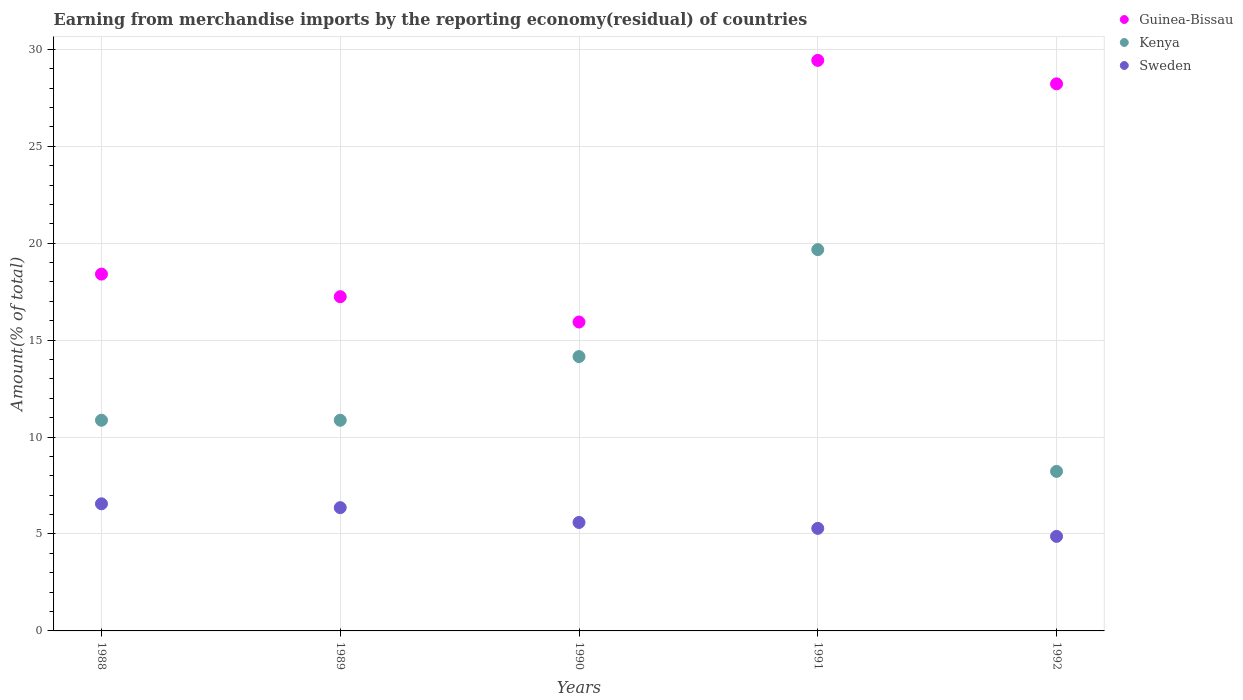What is the percentage of amount earned from merchandise imports in Sweden in 1990?
Give a very brief answer. 5.59. Across all years, what is the maximum percentage of amount earned from merchandise imports in Kenya?
Ensure brevity in your answer.  19.67. Across all years, what is the minimum percentage of amount earned from merchandise imports in Kenya?
Keep it short and to the point. 8.23. In which year was the percentage of amount earned from merchandise imports in Kenya maximum?
Ensure brevity in your answer.  1991. In which year was the percentage of amount earned from merchandise imports in Sweden minimum?
Make the answer very short. 1992. What is the total percentage of amount earned from merchandise imports in Guinea-Bissau in the graph?
Offer a terse response. 109.22. What is the difference between the percentage of amount earned from merchandise imports in Sweden in 1988 and that in 1989?
Make the answer very short. 0.2. What is the difference between the percentage of amount earned from merchandise imports in Guinea-Bissau in 1988 and the percentage of amount earned from merchandise imports in Kenya in 1990?
Your answer should be very brief. 4.25. What is the average percentage of amount earned from merchandise imports in Sweden per year?
Your answer should be compact. 5.73. In the year 1990, what is the difference between the percentage of amount earned from merchandise imports in Kenya and percentage of amount earned from merchandise imports in Guinea-Bissau?
Give a very brief answer. -1.78. In how many years, is the percentage of amount earned from merchandise imports in Guinea-Bissau greater than 25 %?
Offer a terse response. 2. What is the ratio of the percentage of amount earned from merchandise imports in Sweden in 1989 to that in 1992?
Offer a very short reply. 1.3. What is the difference between the highest and the second highest percentage of amount earned from merchandise imports in Kenya?
Offer a terse response. 5.52. What is the difference between the highest and the lowest percentage of amount earned from merchandise imports in Guinea-Bissau?
Offer a very short reply. 13.49. Does the percentage of amount earned from merchandise imports in Guinea-Bissau monotonically increase over the years?
Provide a succinct answer. No. Is the percentage of amount earned from merchandise imports in Kenya strictly greater than the percentage of amount earned from merchandise imports in Sweden over the years?
Offer a very short reply. Yes. How many years are there in the graph?
Keep it short and to the point. 5. What is the difference between two consecutive major ticks on the Y-axis?
Keep it short and to the point. 5. Does the graph contain grids?
Keep it short and to the point. Yes. How many legend labels are there?
Provide a short and direct response. 3. What is the title of the graph?
Make the answer very short. Earning from merchandise imports by the reporting economy(residual) of countries. Does "Central Europe" appear as one of the legend labels in the graph?
Your answer should be compact. No. What is the label or title of the Y-axis?
Make the answer very short. Amount(% of total). What is the Amount(% of total) in Guinea-Bissau in 1988?
Provide a succinct answer. 18.4. What is the Amount(% of total) of Kenya in 1988?
Provide a short and direct response. 10.87. What is the Amount(% of total) of Sweden in 1988?
Your answer should be compact. 6.56. What is the Amount(% of total) of Guinea-Bissau in 1989?
Provide a short and direct response. 17.24. What is the Amount(% of total) in Kenya in 1989?
Offer a terse response. 10.87. What is the Amount(% of total) of Sweden in 1989?
Your response must be concise. 6.36. What is the Amount(% of total) of Guinea-Bissau in 1990?
Offer a very short reply. 15.93. What is the Amount(% of total) of Kenya in 1990?
Keep it short and to the point. 14.15. What is the Amount(% of total) of Sweden in 1990?
Ensure brevity in your answer.  5.59. What is the Amount(% of total) in Guinea-Bissau in 1991?
Provide a succinct answer. 29.43. What is the Amount(% of total) of Kenya in 1991?
Your answer should be compact. 19.67. What is the Amount(% of total) of Sweden in 1991?
Your answer should be compact. 5.29. What is the Amount(% of total) of Guinea-Bissau in 1992?
Your answer should be very brief. 28.22. What is the Amount(% of total) in Kenya in 1992?
Provide a succinct answer. 8.23. What is the Amount(% of total) in Sweden in 1992?
Your response must be concise. 4.88. Across all years, what is the maximum Amount(% of total) in Guinea-Bissau?
Your answer should be compact. 29.43. Across all years, what is the maximum Amount(% of total) in Kenya?
Offer a terse response. 19.67. Across all years, what is the maximum Amount(% of total) of Sweden?
Keep it short and to the point. 6.56. Across all years, what is the minimum Amount(% of total) of Guinea-Bissau?
Your answer should be very brief. 15.93. Across all years, what is the minimum Amount(% of total) in Kenya?
Provide a short and direct response. 8.23. Across all years, what is the minimum Amount(% of total) of Sweden?
Ensure brevity in your answer.  4.88. What is the total Amount(% of total) in Guinea-Bissau in the graph?
Provide a succinct answer. 109.22. What is the total Amount(% of total) of Kenya in the graph?
Provide a succinct answer. 63.78. What is the total Amount(% of total) of Sweden in the graph?
Make the answer very short. 28.67. What is the difference between the Amount(% of total) of Guinea-Bissau in 1988 and that in 1989?
Provide a succinct answer. 1.16. What is the difference between the Amount(% of total) of Sweden in 1988 and that in 1989?
Your answer should be compact. 0.2. What is the difference between the Amount(% of total) of Guinea-Bissau in 1988 and that in 1990?
Keep it short and to the point. 2.47. What is the difference between the Amount(% of total) of Kenya in 1988 and that in 1990?
Provide a succinct answer. -3.28. What is the difference between the Amount(% of total) of Sweden in 1988 and that in 1990?
Your answer should be compact. 0.96. What is the difference between the Amount(% of total) of Guinea-Bissau in 1988 and that in 1991?
Provide a short and direct response. -11.02. What is the difference between the Amount(% of total) in Kenya in 1988 and that in 1991?
Your answer should be compact. -8.8. What is the difference between the Amount(% of total) in Sweden in 1988 and that in 1991?
Ensure brevity in your answer.  1.27. What is the difference between the Amount(% of total) of Guinea-Bissau in 1988 and that in 1992?
Give a very brief answer. -9.81. What is the difference between the Amount(% of total) of Kenya in 1988 and that in 1992?
Make the answer very short. 2.64. What is the difference between the Amount(% of total) in Sweden in 1988 and that in 1992?
Offer a terse response. 1.68. What is the difference between the Amount(% of total) in Guinea-Bissau in 1989 and that in 1990?
Offer a very short reply. 1.31. What is the difference between the Amount(% of total) in Kenya in 1989 and that in 1990?
Your answer should be very brief. -3.28. What is the difference between the Amount(% of total) of Sweden in 1989 and that in 1990?
Make the answer very short. 0.76. What is the difference between the Amount(% of total) of Guinea-Bissau in 1989 and that in 1991?
Your answer should be very brief. -12.19. What is the difference between the Amount(% of total) in Kenya in 1989 and that in 1991?
Provide a succinct answer. -8.8. What is the difference between the Amount(% of total) in Sweden in 1989 and that in 1991?
Offer a terse response. 1.07. What is the difference between the Amount(% of total) of Guinea-Bissau in 1989 and that in 1992?
Make the answer very short. -10.98. What is the difference between the Amount(% of total) in Kenya in 1989 and that in 1992?
Ensure brevity in your answer.  2.64. What is the difference between the Amount(% of total) of Sweden in 1989 and that in 1992?
Offer a very short reply. 1.48. What is the difference between the Amount(% of total) of Guinea-Bissau in 1990 and that in 1991?
Make the answer very short. -13.49. What is the difference between the Amount(% of total) in Kenya in 1990 and that in 1991?
Provide a succinct answer. -5.52. What is the difference between the Amount(% of total) in Sweden in 1990 and that in 1991?
Your answer should be compact. 0.31. What is the difference between the Amount(% of total) of Guinea-Bissau in 1990 and that in 1992?
Ensure brevity in your answer.  -12.28. What is the difference between the Amount(% of total) of Kenya in 1990 and that in 1992?
Give a very brief answer. 5.92. What is the difference between the Amount(% of total) of Sweden in 1990 and that in 1992?
Ensure brevity in your answer.  0.72. What is the difference between the Amount(% of total) of Guinea-Bissau in 1991 and that in 1992?
Give a very brief answer. 1.21. What is the difference between the Amount(% of total) in Kenya in 1991 and that in 1992?
Provide a short and direct response. 11.44. What is the difference between the Amount(% of total) of Sweden in 1991 and that in 1992?
Provide a succinct answer. 0.41. What is the difference between the Amount(% of total) in Guinea-Bissau in 1988 and the Amount(% of total) in Kenya in 1989?
Your answer should be very brief. 7.54. What is the difference between the Amount(% of total) of Guinea-Bissau in 1988 and the Amount(% of total) of Sweden in 1989?
Make the answer very short. 12.05. What is the difference between the Amount(% of total) in Kenya in 1988 and the Amount(% of total) in Sweden in 1989?
Provide a succinct answer. 4.51. What is the difference between the Amount(% of total) in Guinea-Bissau in 1988 and the Amount(% of total) in Kenya in 1990?
Provide a succinct answer. 4.25. What is the difference between the Amount(% of total) in Guinea-Bissau in 1988 and the Amount(% of total) in Sweden in 1990?
Provide a short and direct response. 12.81. What is the difference between the Amount(% of total) in Kenya in 1988 and the Amount(% of total) in Sweden in 1990?
Provide a succinct answer. 5.27. What is the difference between the Amount(% of total) of Guinea-Bissau in 1988 and the Amount(% of total) of Kenya in 1991?
Ensure brevity in your answer.  -1.26. What is the difference between the Amount(% of total) in Guinea-Bissau in 1988 and the Amount(% of total) in Sweden in 1991?
Offer a terse response. 13.12. What is the difference between the Amount(% of total) in Kenya in 1988 and the Amount(% of total) in Sweden in 1991?
Offer a terse response. 5.58. What is the difference between the Amount(% of total) of Guinea-Bissau in 1988 and the Amount(% of total) of Kenya in 1992?
Your response must be concise. 10.18. What is the difference between the Amount(% of total) of Guinea-Bissau in 1988 and the Amount(% of total) of Sweden in 1992?
Keep it short and to the point. 13.53. What is the difference between the Amount(% of total) of Kenya in 1988 and the Amount(% of total) of Sweden in 1992?
Offer a very short reply. 5.99. What is the difference between the Amount(% of total) in Guinea-Bissau in 1989 and the Amount(% of total) in Kenya in 1990?
Your answer should be very brief. 3.09. What is the difference between the Amount(% of total) of Guinea-Bissau in 1989 and the Amount(% of total) of Sweden in 1990?
Provide a succinct answer. 11.64. What is the difference between the Amount(% of total) of Kenya in 1989 and the Amount(% of total) of Sweden in 1990?
Offer a very short reply. 5.27. What is the difference between the Amount(% of total) of Guinea-Bissau in 1989 and the Amount(% of total) of Kenya in 1991?
Your answer should be very brief. -2.43. What is the difference between the Amount(% of total) of Guinea-Bissau in 1989 and the Amount(% of total) of Sweden in 1991?
Your answer should be compact. 11.95. What is the difference between the Amount(% of total) of Kenya in 1989 and the Amount(% of total) of Sweden in 1991?
Offer a very short reply. 5.58. What is the difference between the Amount(% of total) of Guinea-Bissau in 1989 and the Amount(% of total) of Kenya in 1992?
Give a very brief answer. 9.01. What is the difference between the Amount(% of total) of Guinea-Bissau in 1989 and the Amount(% of total) of Sweden in 1992?
Provide a short and direct response. 12.36. What is the difference between the Amount(% of total) in Kenya in 1989 and the Amount(% of total) in Sweden in 1992?
Your answer should be very brief. 5.99. What is the difference between the Amount(% of total) in Guinea-Bissau in 1990 and the Amount(% of total) in Kenya in 1991?
Your answer should be very brief. -3.73. What is the difference between the Amount(% of total) in Guinea-Bissau in 1990 and the Amount(% of total) in Sweden in 1991?
Provide a succinct answer. 10.64. What is the difference between the Amount(% of total) of Kenya in 1990 and the Amount(% of total) of Sweden in 1991?
Ensure brevity in your answer.  8.86. What is the difference between the Amount(% of total) in Guinea-Bissau in 1990 and the Amount(% of total) in Kenya in 1992?
Make the answer very short. 7.7. What is the difference between the Amount(% of total) of Guinea-Bissau in 1990 and the Amount(% of total) of Sweden in 1992?
Give a very brief answer. 11.06. What is the difference between the Amount(% of total) in Kenya in 1990 and the Amount(% of total) in Sweden in 1992?
Give a very brief answer. 9.27. What is the difference between the Amount(% of total) of Guinea-Bissau in 1991 and the Amount(% of total) of Kenya in 1992?
Ensure brevity in your answer.  21.2. What is the difference between the Amount(% of total) in Guinea-Bissau in 1991 and the Amount(% of total) in Sweden in 1992?
Keep it short and to the point. 24.55. What is the difference between the Amount(% of total) in Kenya in 1991 and the Amount(% of total) in Sweden in 1992?
Offer a terse response. 14.79. What is the average Amount(% of total) in Guinea-Bissau per year?
Ensure brevity in your answer.  21.84. What is the average Amount(% of total) of Kenya per year?
Provide a short and direct response. 12.76. What is the average Amount(% of total) of Sweden per year?
Your answer should be very brief. 5.73. In the year 1988, what is the difference between the Amount(% of total) of Guinea-Bissau and Amount(% of total) of Kenya?
Offer a terse response. 7.54. In the year 1988, what is the difference between the Amount(% of total) in Guinea-Bissau and Amount(% of total) in Sweden?
Offer a terse response. 11.85. In the year 1988, what is the difference between the Amount(% of total) of Kenya and Amount(% of total) of Sweden?
Provide a short and direct response. 4.31. In the year 1989, what is the difference between the Amount(% of total) in Guinea-Bissau and Amount(% of total) in Kenya?
Keep it short and to the point. 6.37. In the year 1989, what is the difference between the Amount(% of total) in Guinea-Bissau and Amount(% of total) in Sweden?
Provide a succinct answer. 10.88. In the year 1989, what is the difference between the Amount(% of total) in Kenya and Amount(% of total) in Sweden?
Provide a succinct answer. 4.51. In the year 1990, what is the difference between the Amount(% of total) of Guinea-Bissau and Amount(% of total) of Kenya?
Provide a short and direct response. 1.78. In the year 1990, what is the difference between the Amount(% of total) of Guinea-Bissau and Amount(% of total) of Sweden?
Provide a short and direct response. 10.34. In the year 1990, what is the difference between the Amount(% of total) of Kenya and Amount(% of total) of Sweden?
Keep it short and to the point. 8.56. In the year 1991, what is the difference between the Amount(% of total) of Guinea-Bissau and Amount(% of total) of Kenya?
Your answer should be compact. 9.76. In the year 1991, what is the difference between the Amount(% of total) in Guinea-Bissau and Amount(% of total) in Sweden?
Provide a short and direct response. 24.14. In the year 1991, what is the difference between the Amount(% of total) of Kenya and Amount(% of total) of Sweden?
Provide a short and direct response. 14.38. In the year 1992, what is the difference between the Amount(% of total) in Guinea-Bissau and Amount(% of total) in Kenya?
Offer a terse response. 19.99. In the year 1992, what is the difference between the Amount(% of total) of Guinea-Bissau and Amount(% of total) of Sweden?
Keep it short and to the point. 23.34. In the year 1992, what is the difference between the Amount(% of total) in Kenya and Amount(% of total) in Sweden?
Offer a very short reply. 3.35. What is the ratio of the Amount(% of total) in Guinea-Bissau in 1988 to that in 1989?
Keep it short and to the point. 1.07. What is the ratio of the Amount(% of total) of Kenya in 1988 to that in 1989?
Your answer should be compact. 1. What is the ratio of the Amount(% of total) of Sweden in 1988 to that in 1989?
Give a very brief answer. 1.03. What is the ratio of the Amount(% of total) in Guinea-Bissau in 1988 to that in 1990?
Your response must be concise. 1.16. What is the ratio of the Amount(% of total) of Kenya in 1988 to that in 1990?
Your answer should be compact. 0.77. What is the ratio of the Amount(% of total) in Sweden in 1988 to that in 1990?
Provide a short and direct response. 1.17. What is the ratio of the Amount(% of total) in Guinea-Bissau in 1988 to that in 1991?
Keep it short and to the point. 0.63. What is the ratio of the Amount(% of total) in Kenya in 1988 to that in 1991?
Ensure brevity in your answer.  0.55. What is the ratio of the Amount(% of total) of Sweden in 1988 to that in 1991?
Your answer should be compact. 1.24. What is the ratio of the Amount(% of total) of Guinea-Bissau in 1988 to that in 1992?
Make the answer very short. 0.65. What is the ratio of the Amount(% of total) of Kenya in 1988 to that in 1992?
Offer a terse response. 1.32. What is the ratio of the Amount(% of total) of Sweden in 1988 to that in 1992?
Your response must be concise. 1.34. What is the ratio of the Amount(% of total) in Guinea-Bissau in 1989 to that in 1990?
Make the answer very short. 1.08. What is the ratio of the Amount(% of total) of Kenya in 1989 to that in 1990?
Offer a terse response. 0.77. What is the ratio of the Amount(% of total) in Sweden in 1989 to that in 1990?
Provide a short and direct response. 1.14. What is the ratio of the Amount(% of total) of Guinea-Bissau in 1989 to that in 1991?
Offer a very short reply. 0.59. What is the ratio of the Amount(% of total) in Kenya in 1989 to that in 1991?
Give a very brief answer. 0.55. What is the ratio of the Amount(% of total) of Sweden in 1989 to that in 1991?
Provide a short and direct response. 1.2. What is the ratio of the Amount(% of total) in Guinea-Bissau in 1989 to that in 1992?
Provide a succinct answer. 0.61. What is the ratio of the Amount(% of total) in Kenya in 1989 to that in 1992?
Your answer should be compact. 1.32. What is the ratio of the Amount(% of total) in Sweden in 1989 to that in 1992?
Provide a short and direct response. 1.3. What is the ratio of the Amount(% of total) in Guinea-Bissau in 1990 to that in 1991?
Provide a succinct answer. 0.54. What is the ratio of the Amount(% of total) of Kenya in 1990 to that in 1991?
Provide a short and direct response. 0.72. What is the ratio of the Amount(% of total) in Sweden in 1990 to that in 1991?
Your answer should be very brief. 1.06. What is the ratio of the Amount(% of total) in Guinea-Bissau in 1990 to that in 1992?
Keep it short and to the point. 0.56. What is the ratio of the Amount(% of total) of Kenya in 1990 to that in 1992?
Your answer should be compact. 1.72. What is the ratio of the Amount(% of total) in Sweden in 1990 to that in 1992?
Ensure brevity in your answer.  1.15. What is the ratio of the Amount(% of total) of Guinea-Bissau in 1991 to that in 1992?
Ensure brevity in your answer.  1.04. What is the ratio of the Amount(% of total) in Kenya in 1991 to that in 1992?
Offer a very short reply. 2.39. What is the ratio of the Amount(% of total) in Sweden in 1991 to that in 1992?
Make the answer very short. 1.08. What is the difference between the highest and the second highest Amount(% of total) of Guinea-Bissau?
Make the answer very short. 1.21. What is the difference between the highest and the second highest Amount(% of total) of Kenya?
Give a very brief answer. 5.52. What is the difference between the highest and the second highest Amount(% of total) in Sweden?
Your answer should be compact. 0.2. What is the difference between the highest and the lowest Amount(% of total) in Guinea-Bissau?
Offer a terse response. 13.49. What is the difference between the highest and the lowest Amount(% of total) in Kenya?
Offer a terse response. 11.44. What is the difference between the highest and the lowest Amount(% of total) of Sweden?
Keep it short and to the point. 1.68. 